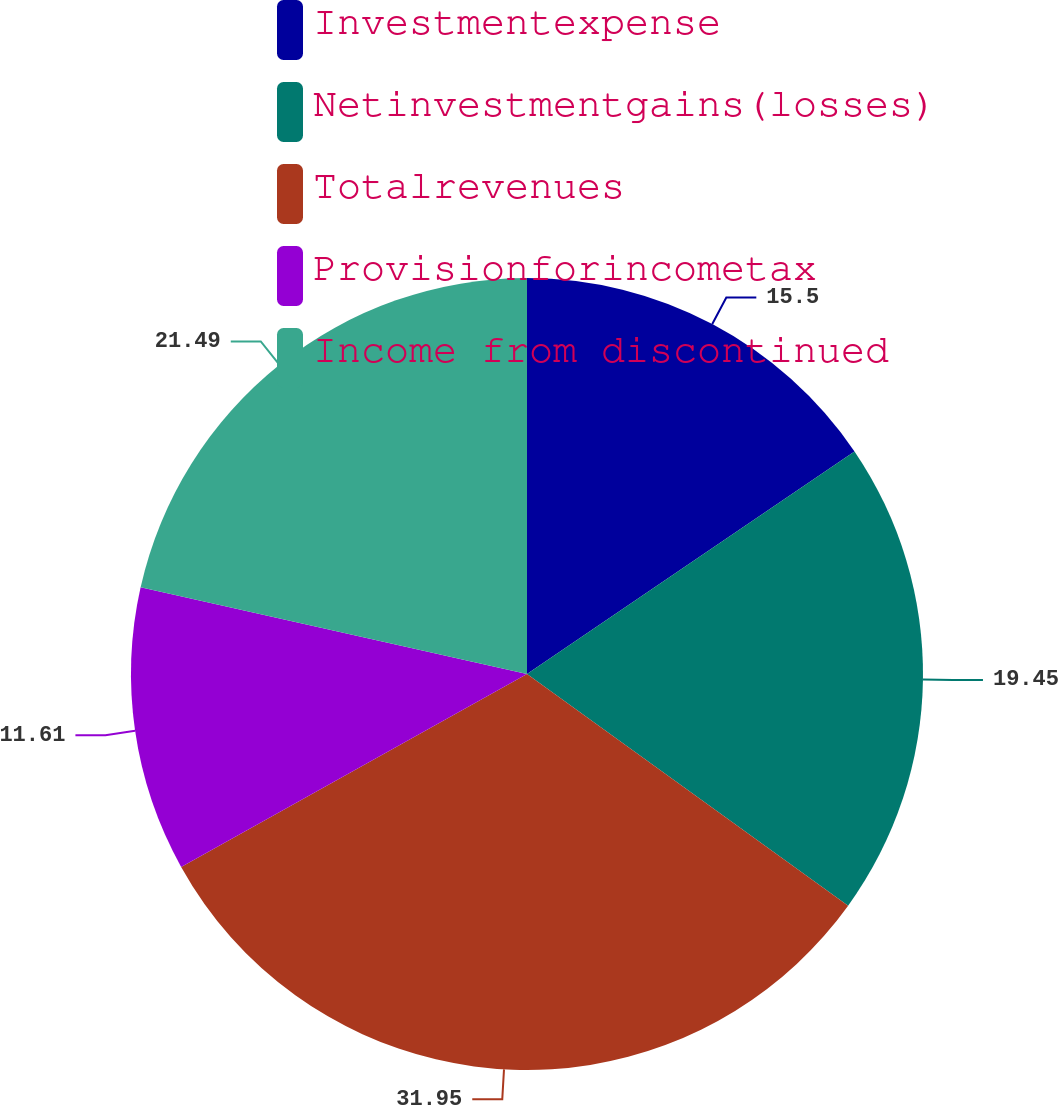Convert chart. <chart><loc_0><loc_0><loc_500><loc_500><pie_chart><fcel>Investmentexpense<fcel>Netinvestmentgains(losses)<fcel>Totalrevenues<fcel>Provisionforincometax<fcel>Income from discontinued<nl><fcel>15.5%<fcel>19.45%<fcel>31.96%<fcel>11.61%<fcel>21.49%<nl></chart> 